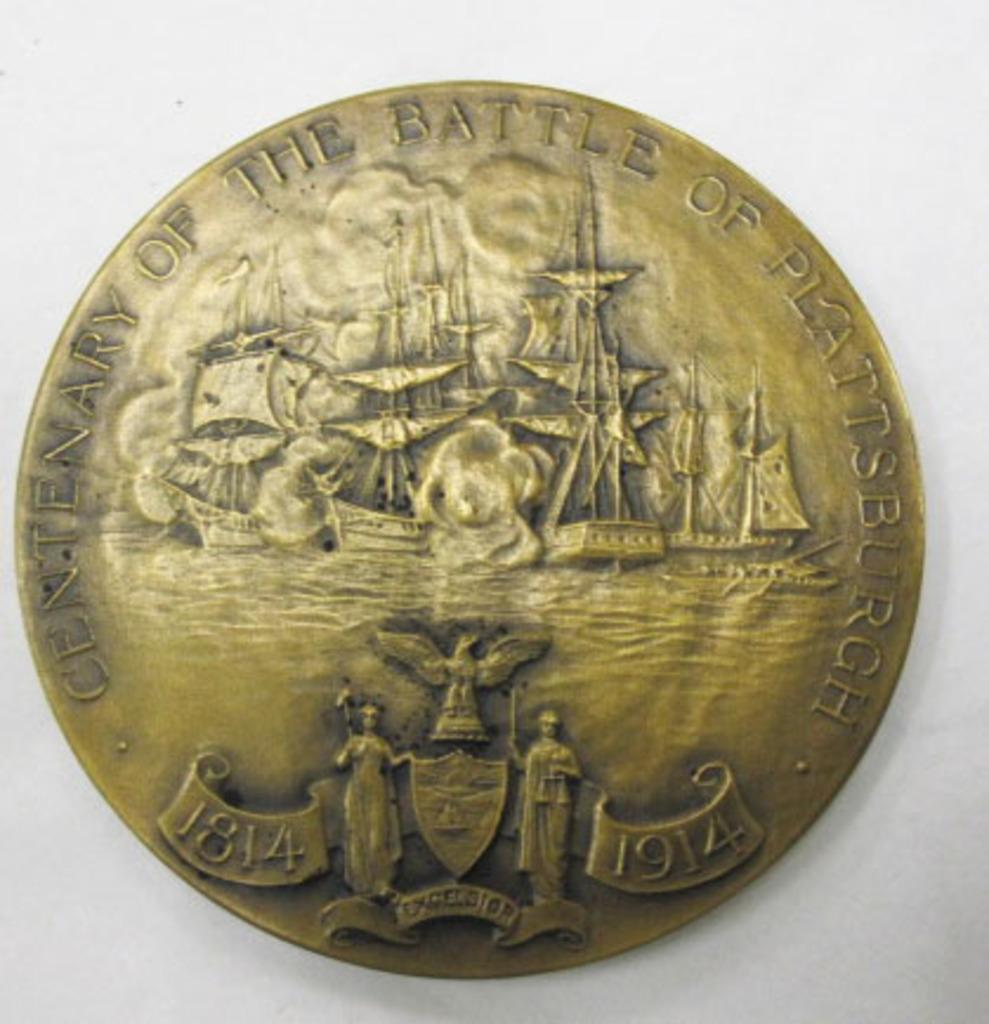<image>
Give a short and clear explanation of the subsequent image. A 1914 coin commemorates the battle of Plattsburgh. 